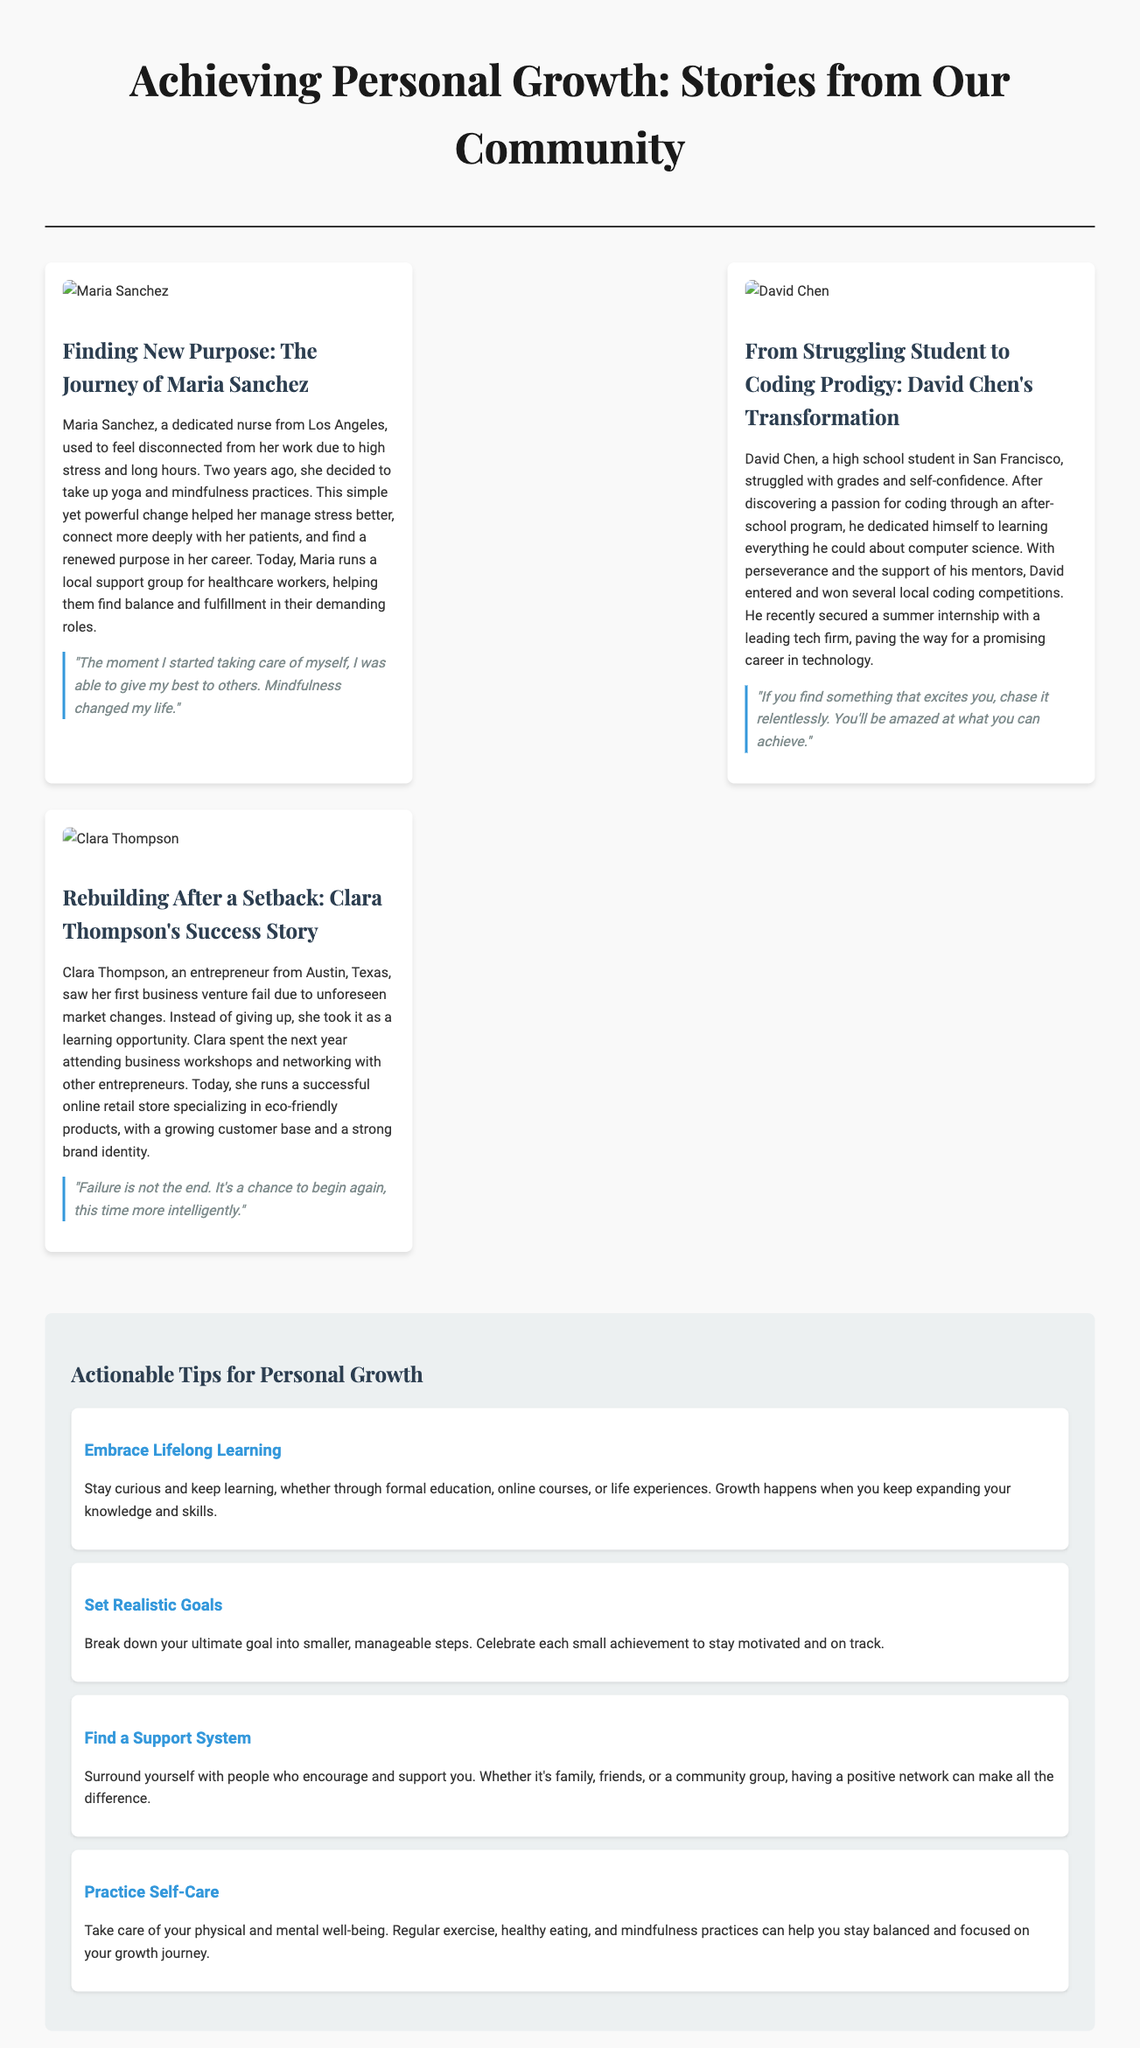What is the main theme of the section? The main theme of the section is reflected in the title, which discusses personal growth stories from the community.
Answer: Achieving Personal Growth Who is the first individual featured in a story? The first individual mentioned in the document is Maria Sanchez, as seen in her highlighted story.
Answer: Maria Sanchez What is Maria Sanchez's profession? Maria Sanchez is described in the document as a dedicated nurse.
Answer: Nurse What did David Chen discover that changed his career path? The document states that David Chen discovered a passion for coding which changed his career course.
Answer: Passion for coding What advice did Clara Thompson share about failure? Clara Thompson emphasizes that failure is a learning opportunity and a chance to start fresh.
Answer: It's a chance to begin again How many actionable tips for personal growth are provided? The document lists a total of four actionable tips for personal growth.
Answer: Four What type of products does Clara Thompson's business specialize in? Clara Thompson's business focuses on eco-friendly products, as specifically mentioned in her story.
Answer: Eco-friendly products What is one of the tips for personal growth mentioned in the document? The document refers to various tips for personal growth, including the importance of practicing self-care.
Answer: Practice Self-Care 